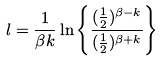Convert formula to latex. <formula><loc_0><loc_0><loc_500><loc_500>l = \frac { 1 } { \beta k } \ln \left \{ \frac { ( \frac { 1 } { 2 } ) ^ { \beta - k } } { ( \frac { 1 } { 2 } ) ^ { \beta + k } } \right \}</formula> 